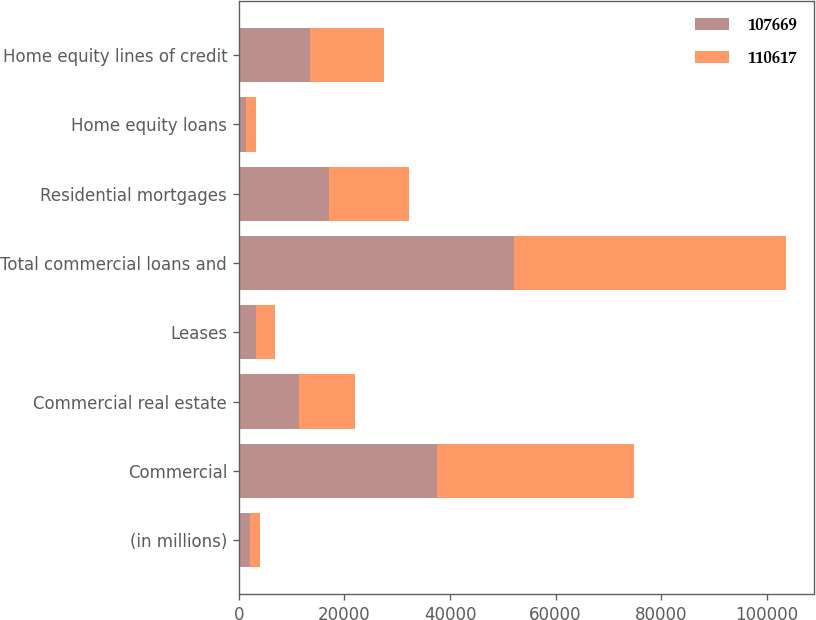Convert chart to OTSL. <chart><loc_0><loc_0><loc_500><loc_500><stacked_bar_chart><ecel><fcel>(in millions)<fcel>Commercial<fcel>Commercial real estate<fcel>Leases<fcel>Total commercial loans and<fcel>Residential mortgages<fcel>Home equity loans<fcel>Home equity lines of credit<nl><fcel>107669<fcel>2017<fcel>37562<fcel>11308<fcel>3161<fcel>52031<fcel>17045<fcel>1392<fcel>13483<nl><fcel>110617<fcel>2016<fcel>37274<fcel>10624<fcel>3753<fcel>51651<fcel>15115<fcel>1858<fcel>14100<nl></chart> 